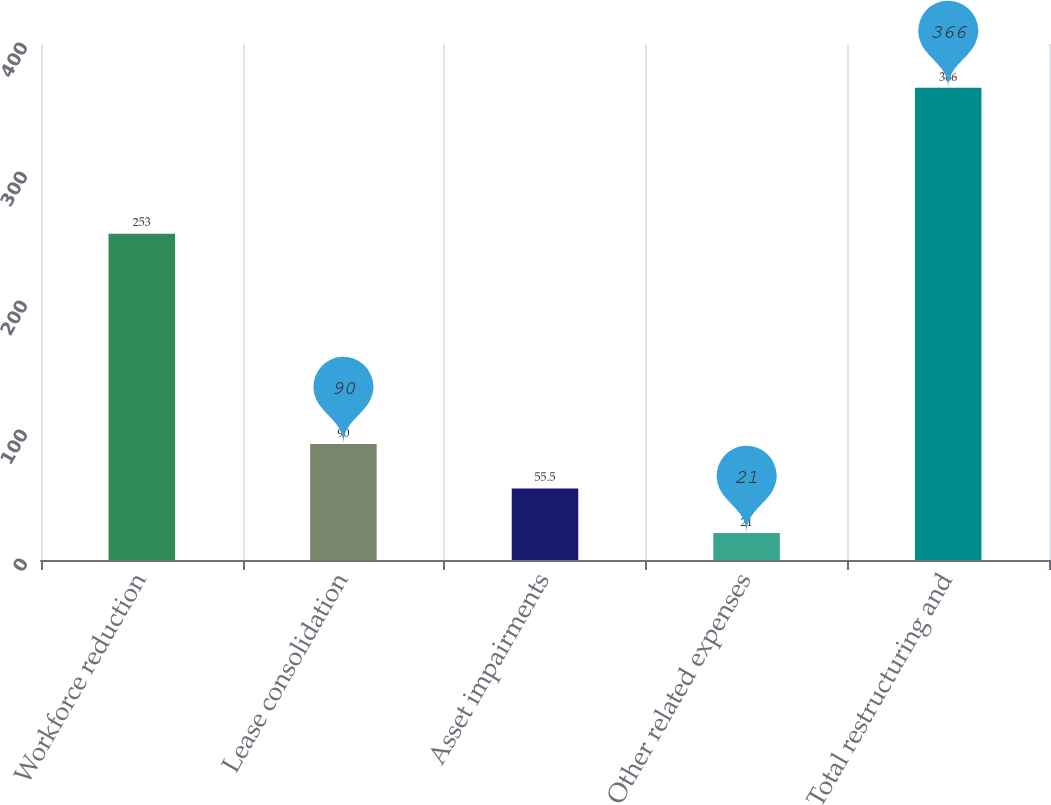<chart> <loc_0><loc_0><loc_500><loc_500><bar_chart><fcel>Workforce reduction<fcel>Lease consolidation<fcel>Asset impairments<fcel>Other related expenses<fcel>Total restructuring and<nl><fcel>253<fcel>90<fcel>55.5<fcel>21<fcel>366<nl></chart> 